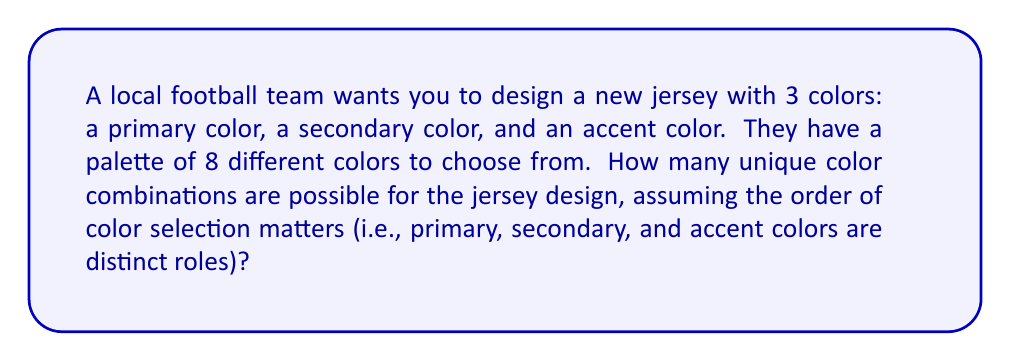Teach me how to tackle this problem. Let's approach this step-by-step:

1) We are selecting 3 colors from a set of 8 colors.

2) The order matters, as each color has a specific role (primary, secondary, or accent).

3) We can select the same color more than once (e.g., the primary and secondary could be the same color).

4) This scenario is a perfect example of permutation with repetition.

5) The formula for permutation with repetition is:

   $$n^r$$

   Where $n$ is the number of items to choose from, and $r$ is the number of items being chosen.

6) In this case:
   $n = 8$ (8 colors to choose from)
   $r = 3$ (3 colors being chosen)

7) Plugging these values into our formula:

   $$8^3 = 8 \times 8 \times 8 = 512$$

Therefore, there are 512 possible unique color combinations for the jersey design.
Answer: 512 